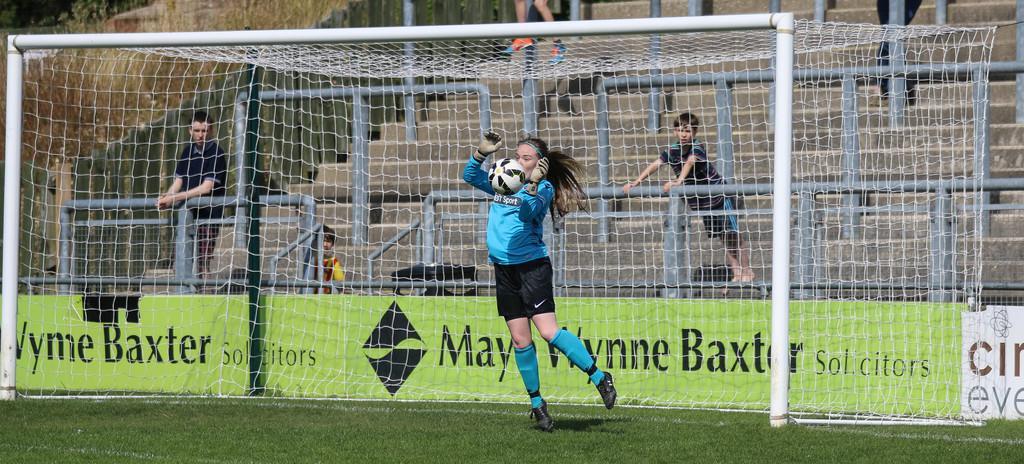Please provide a concise description of this image. In the middle of the picture, we see a girl in blue T-shirt is trying to catch the ball. Behind her, we see a football net. Behind that, we see a green color board with some text written on it. Behind that, we see people are standing on the staircase. In front of them, we see a railing. On the left side, we see a wall. At the bottom of the picture, we see grass. This picture might be clicked in the football field. 